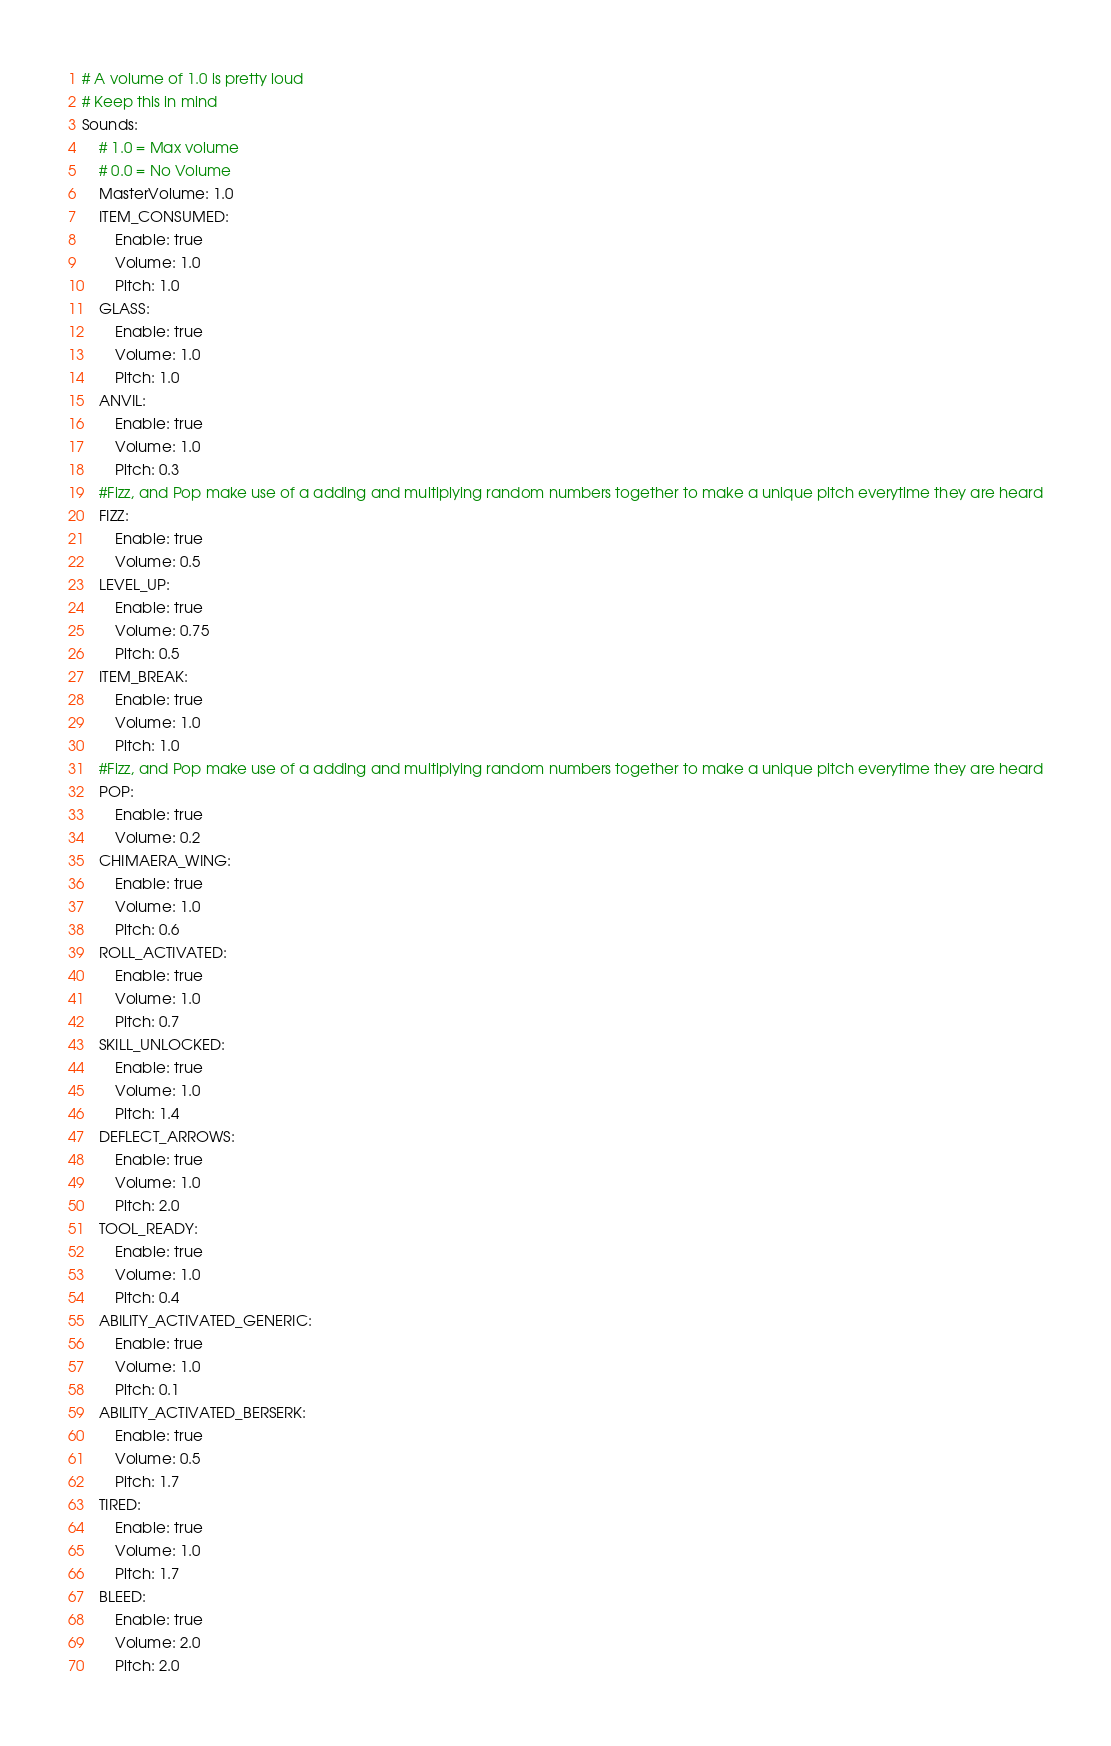Convert code to text. <code><loc_0><loc_0><loc_500><loc_500><_YAML_># A volume of 1.0 is pretty loud
# Keep this in mind
Sounds:
    # 1.0 = Max volume
    # 0.0 = No Volume
    MasterVolume: 1.0
    ITEM_CONSUMED:
        Enable: true
        Volume: 1.0
        Pitch: 1.0
    GLASS:
        Enable: true
        Volume: 1.0
        Pitch: 1.0
    ANVIL:
        Enable: true
        Volume: 1.0
        Pitch: 0.3
    #Fizz, and Pop make use of a adding and multiplying random numbers together to make a unique pitch everytime they are heard
    FIZZ:
        Enable: true
        Volume: 0.5
    LEVEL_UP:
        Enable: true
        Volume: 0.75
        Pitch: 0.5
    ITEM_BREAK:
        Enable: true
        Volume: 1.0
        Pitch: 1.0
    #Fizz, and Pop make use of a adding and multiplying random numbers together to make a unique pitch everytime they are heard
    POP:
        Enable: true
        Volume: 0.2
    CHIMAERA_WING:
        Enable: true
        Volume: 1.0
        Pitch: 0.6
    ROLL_ACTIVATED:
        Enable: true
        Volume: 1.0
        Pitch: 0.7
    SKILL_UNLOCKED:
        Enable: true
        Volume: 1.0
        Pitch: 1.4
    DEFLECT_ARROWS:
        Enable: true
        Volume: 1.0
        Pitch: 2.0
    TOOL_READY:
        Enable: true
        Volume: 1.0
        Pitch: 0.4
    ABILITY_ACTIVATED_GENERIC:
        Enable: true
        Volume: 1.0
        Pitch: 0.1
    ABILITY_ACTIVATED_BERSERK:
        Enable: true
        Volume: 0.5
        Pitch: 1.7
    TIRED:
        Enable: true
        Volume: 1.0
        Pitch: 1.7
    BLEED:
        Enable: true
        Volume: 2.0
        Pitch: 2.0</code> 